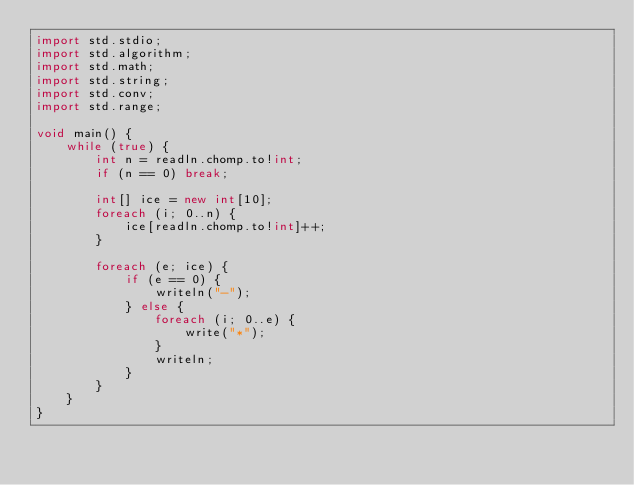<code> <loc_0><loc_0><loc_500><loc_500><_D_>import std.stdio;
import std.algorithm;
import std.math;
import std.string;
import std.conv;
import std.range;

void main() {
    while (true) {
        int n = readln.chomp.to!int;
        if (n == 0) break;

        int[] ice = new int[10];
        foreach (i; 0..n) {
            ice[readln.chomp.to!int]++;
        }

        foreach (e; ice) {
            if (e == 0) {
                writeln("-");
            } else {
                foreach (i; 0..e) {
                    write("*");
                }
                writeln;
            }
        }
    }
}</code> 